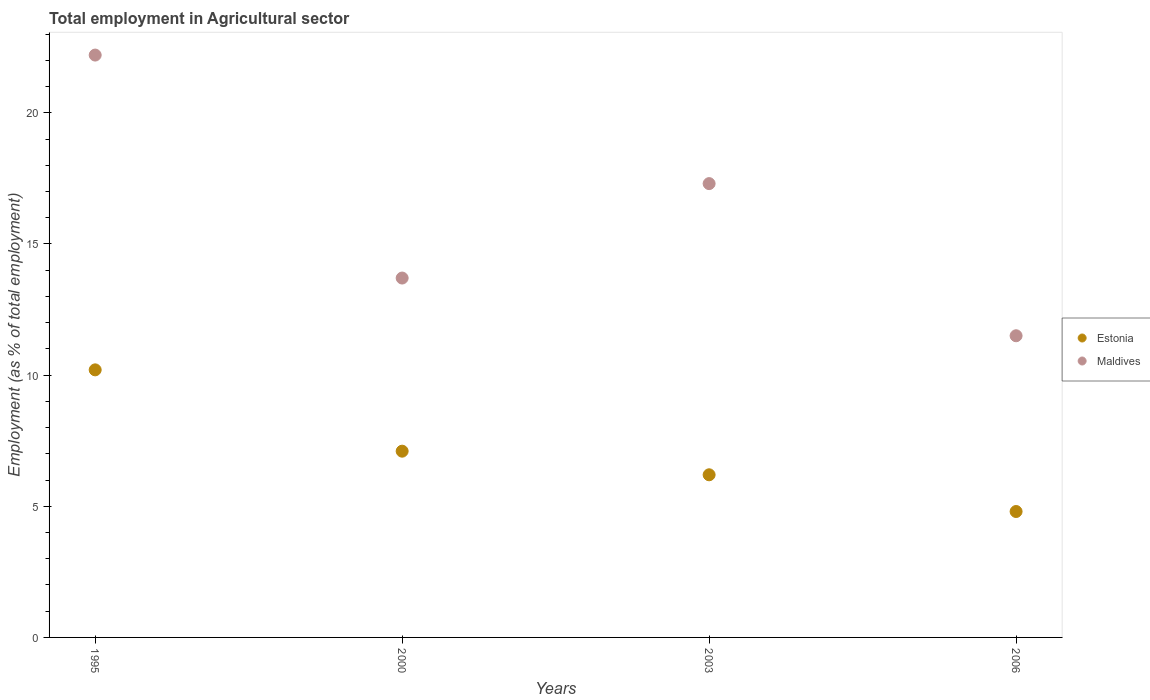Is the number of dotlines equal to the number of legend labels?
Your answer should be compact. Yes. What is the employment in agricultural sector in Maldives in 2003?
Your answer should be compact. 17.3. Across all years, what is the maximum employment in agricultural sector in Maldives?
Provide a short and direct response. 22.2. Across all years, what is the minimum employment in agricultural sector in Maldives?
Provide a short and direct response. 11.5. In which year was the employment in agricultural sector in Estonia maximum?
Ensure brevity in your answer.  1995. In which year was the employment in agricultural sector in Estonia minimum?
Provide a short and direct response. 2006. What is the total employment in agricultural sector in Estonia in the graph?
Give a very brief answer. 28.3. What is the difference between the employment in agricultural sector in Estonia in 2000 and that in 2006?
Your answer should be very brief. 2.3. What is the difference between the employment in agricultural sector in Estonia in 2006 and the employment in agricultural sector in Maldives in 1995?
Keep it short and to the point. -17.4. What is the average employment in agricultural sector in Estonia per year?
Offer a very short reply. 7.07. In the year 2006, what is the difference between the employment in agricultural sector in Maldives and employment in agricultural sector in Estonia?
Provide a short and direct response. 6.7. In how many years, is the employment in agricultural sector in Maldives greater than 7 %?
Make the answer very short. 4. What is the ratio of the employment in agricultural sector in Estonia in 1995 to that in 2006?
Keep it short and to the point. 2.12. Is the employment in agricultural sector in Estonia in 2000 less than that in 2006?
Your response must be concise. No. What is the difference between the highest and the second highest employment in agricultural sector in Maldives?
Your response must be concise. 4.9. What is the difference between the highest and the lowest employment in agricultural sector in Maldives?
Provide a short and direct response. 10.7. In how many years, is the employment in agricultural sector in Maldives greater than the average employment in agricultural sector in Maldives taken over all years?
Your response must be concise. 2. Is the employment in agricultural sector in Maldives strictly less than the employment in agricultural sector in Estonia over the years?
Make the answer very short. No. How many years are there in the graph?
Your response must be concise. 4. What is the difference between two consecutive major ticks on the Y-axis?
Your answer should be compact. 5. How many legend labels are there?
Offer a terse response. 2. What is the title of the graph?
Ensure brevity in your answer.  Total employment in Agricultural sector. What is the label or title of the Y-axis?
Your answer should be very brief. Employment (as % of total employment). What is the Employment (as % of total employment) in Estonia in 1995?
Make the answer very short. 10.2. What is the Employment (as % of total employment) in Maldives in 1995?
Your answer should be very brief. 22.2. What is the Employment (as % of total employment) of Estonia in 2000?
Your answer should be compact. 7.1. What is the Employment (as % of total employment) in Maldives in 2000?
Your answer should be very brief. 13.7. What is the Employment (as % of total employment) of Estonia in 2003?
Provide a succinct answer. 6.2. What is the Employment (as % of total employment) of Maldives in 2003?
Keep it short and to the point. 17.3. What is the Employment (as % of total employment) in Estonia in 2006?
Offer a terse response. 4.8. What is the Employment (as % of total employment) in Maldives in 2006?
Offer a terse response. 11.5. Across all years, what is the maximum Employment (as % of total employment) in Estonia?
Your answer should be compact. 10.2. Across all years, what is the maximum Employment (as % of total employment) of Maldives?
Your response must be concise. 22.2. Across all years, what is the minimum Employment (as % of total employment) of Estonia?
Provide a short and direct response. 4.8. Across all years, what is the minimum Employment (as % of total employment) in Maldives?
Provide a short and direct response. 11.5. What is the total Employment (as % of total employment) of Estonia in the graph?
Your answer should be very brief. 28.3. What is the total Employment (as % of total employment) of Maldives in the graph?
Give a very brief answer. 64.7. What is the difference between the Employment (as % of total employment) in Estonia in 1995 and that in 2000?
Your answer should be very brief. 3.1. What is the difference between the Employment (as % of total employment) in Maldives in 1995 and that in 2000?
Give a very brief answer. 8.5. What is the difference between the Employment (as % of total employment) of Estonia in 2000 and that in 2003?
Give a very brief answer. 0.9. What is the difference between the Employment (as % of total employment) in Estonia in 2000 and that in 2006?
Your answer should be very brief. 2.3. What is the difference between the Employment (as % of total employment) of Maldives in 2003 and that in 2006?
Keep it short and to the point. 5.8. What is the difference between the Employment (as % of total employment) in Estonia in 1995 and the Employment (as % of total employment) in Maldives in 2003?
Provide a short and direct response. -7.1. What is the difference between the Employment (as % of total employment) in Estonia in 2000 and the Employment (as % of total employment) in Maldives in 2006?
Keep it short and to the point. -4.4. What is the difference between the Employment (as % of total employment) of Estonia in 2003 and the Employment (as % of total employment) of Maldives in 2006?
Offer a terse response. -5.3. What is the average Employment (as % of total employment) in Estonia per year?
Your answer should be compact. 7.08. What is the average Employment (as % of total employment) in Maldives per year?
Your answer should be very brief. 16.18. In the year 2000, what is the difference between the Employment (as % of total employment) of Estonia and Employment (as % of total employment) of Maldives?
Offer a very short reply. -6.6. In the year 2003, what is the difference between the Employment (as % of total employment) in Estonia and Employment (as % of total employment) in Maldives?
Offer a very short reply. -11.1. What is the ratio of the Employment (as % of total employment) of Estonia in 1995 to that in 2000?
Keep it short and to the point. 1.44. What is the ratio of the Employment (as % of total employment) in Maldives in 1995 to that in 2000?
Make the answer very short. 1.62. What is the ratio of the Employment (as % of total employment) in Estonia in 1995 to that in 2003?
Give a very brief answer. 1.65. What is the ratio of the Employment (as % of total employment) in Maldives in 1995 to that in 2003?
Provide a succinct answer. 1.28. What is the ratio of the Employment (as % of total employment) in Estonia in 1995 to that in 2006?
Your answer should be very brief. 2.12. What is the ratio of the Employment (as % of total employment) of Maldives in 1995 to that in 2006?
Make the answer very short. 1.93. What is the ratio of the Employment (as % of total employment) in Estonia in 2000 to that in 2003?
Provide a succinct answer. 1.15. What is the ratio of the Employment (as % of total employment) in Maldives in 2000 to that in 2003?
Offer a very short reply. 0.79. What is the ratio of the Employment (as % of total employment) in Estonia in 2000 to that in 2006?
Your answer should be compact. 1.48. What is the ratio of the Employment (as % of total employment) of Maldives in 2000 to that in 2006?
Make the answer very short. 1.19. What is the ratio of the Employment (as % of total employment) of Estonia in 2003 to that in 2006?
Ensure brevity in your answer.  1.29. What is the ratio of the Employment (as % of total employment) in Maldives in 2003 to that in 2006?
Your answer should be compact. 1.5. What is the difference between the highest and the second highest Employment (as % of total employment) in Estonia?
Offer a terse response. 3.1. What is the difference between the highest and the lowest Employment (as % of total employment) of Estonia?
Your response must be concise. 5.4. 